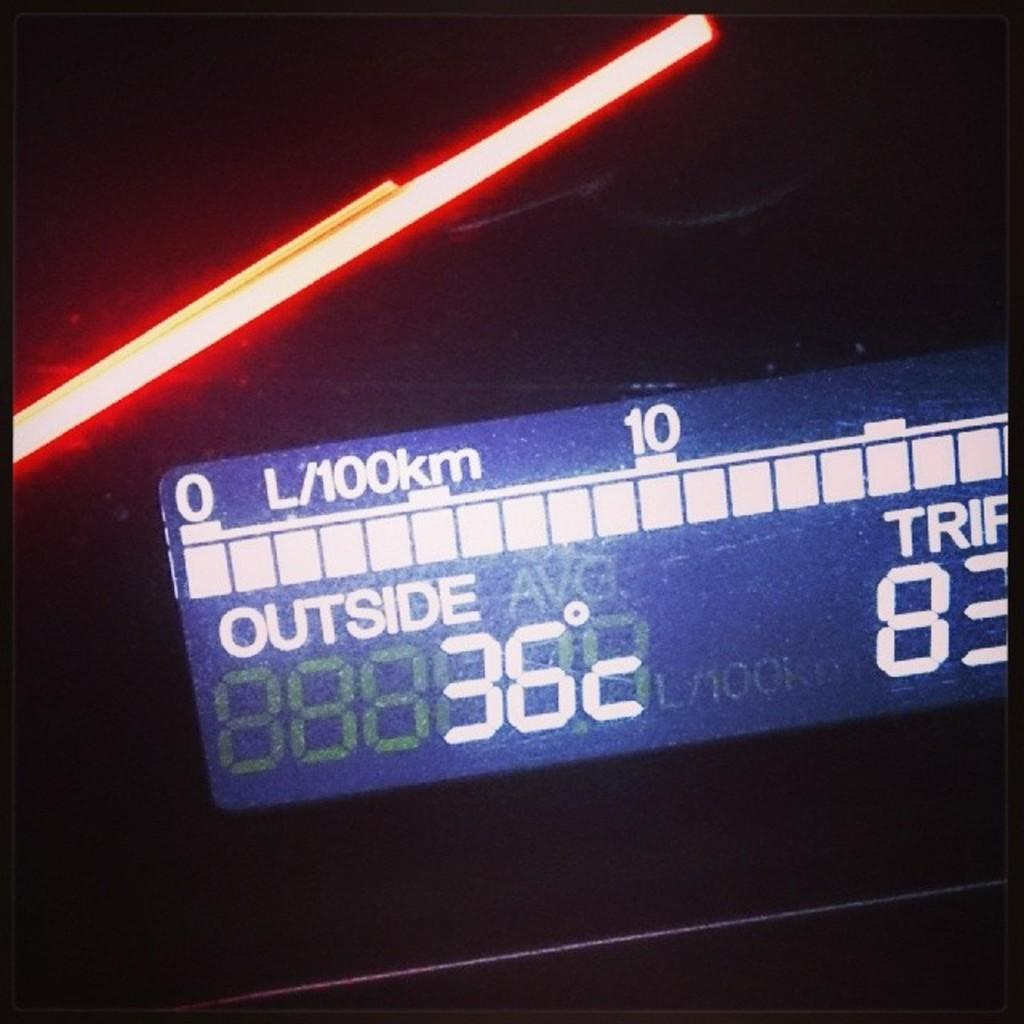<image>
Share a concise interpretation of the image provided. A digital display says that the outside temperature is 36 degrees. 